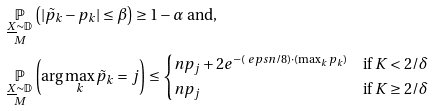<formula> <loc_0><loc_0><loc_500><loc_500>& \underset { \substack { \underline { X } \sim \mathbb { D } \\ M } } { \mathbb { P } } \left ( | \tilde { p } _ { k } - p _ { k } | \leq \beta \right ) \geq 1 - \alpha \text { and,} \\ & \underset { \substack { \underline { X } \sim \mathbb { D } \\ M } } { \mathbb { P } } \left ( \arg \max _ { k } \tilde { p } _ { k } = j \right ) \leq \begin{cases} n p _ { j } + 2 e ^ { - ( \ e p s n / 8 ) \cdot ( \max _ { k } p _ { k } ) } & \text {if } K < 2 / \delta \\ n p _ { j } & \text {if } K \geq 2 / \delta \end{cases}</formula> 